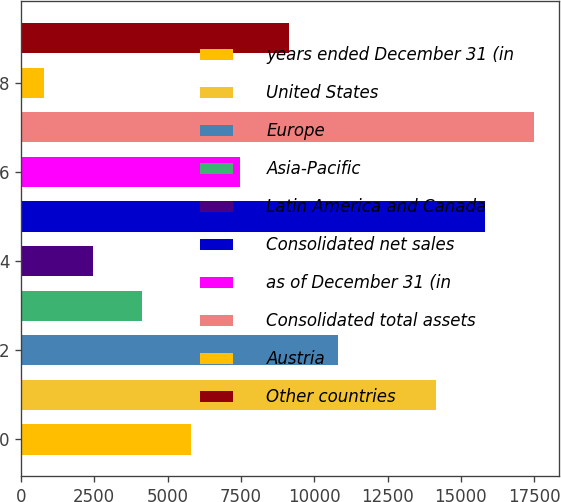<chart> <loc_0><loc_0><loc_500><loc_500><bar_chart><fcel>years ended December 31 (in<fcel>United States<fcel>Europe<fcel>Asia-Pacific<fcel>Latin America and Canada<fcel>Consolidated net sales<fcel>as of December 31 (in<fcel>Consolidated total assets<fcel>Austria<fcel>Other countries<nl><fcel>5797.6<fcel>14148.6<fcel>10808.2<fcel>4127.4<fcel>2457.2<fcel>15818.8<fcel>7467.8<fcel>17489<fcel>787<fcel>9138<nl></chart> 